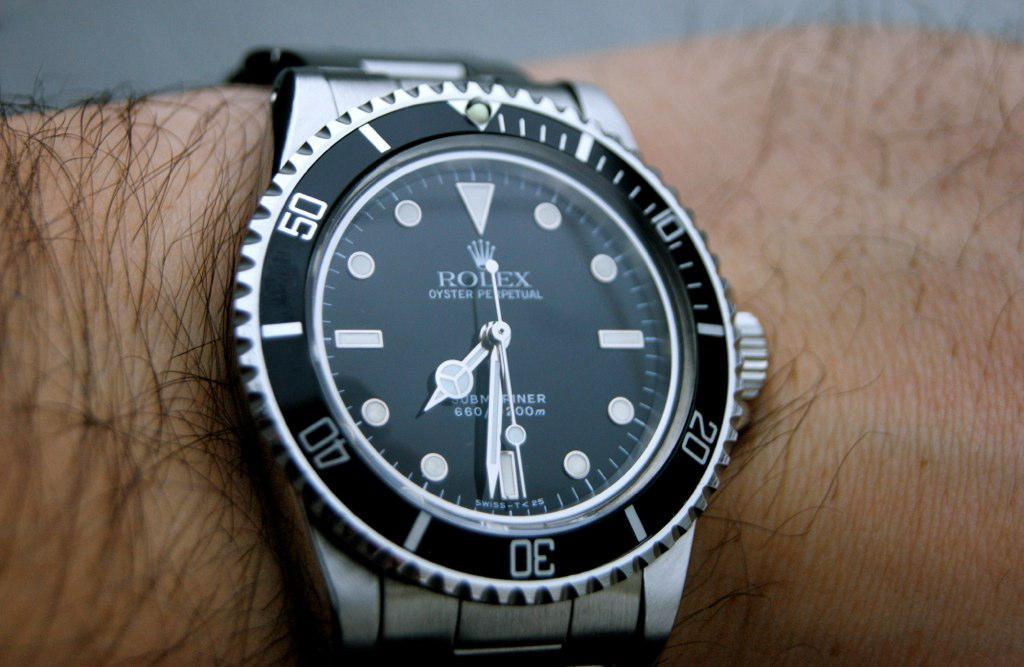<image>
Describe the image concisely. A Rolex watch is silver and black and on a wrist. 